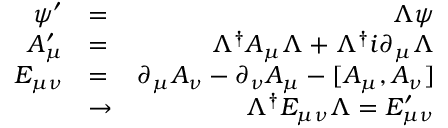<formula> <loc_0><loc_0><loc_500><loc_500>\begin{array} { r l r } { \psi ^ { \prime } } & { = } & { \Lambda \psi } \\ { A _ { \mu } ^ { \prime } } & { = } & { \Lambda ^ { \dagger } A _ { \mu } \Lambda + \Lambda ^ { \dagger } i \partial _ { \mu } \Lambda } \\ { E _ { \mu \nu } } & { = } & { \partial _ { \mu } A _ { \nu } - \partial _ { \nu } A _ { \mu } - [ A _ { \mu } , A _ { \nu } ] } \\ & { \to } & { \Lambda ^ { \dagger } E _ { \mu \nu } \Lambda = E _ { \mu \nu } ^ { \prime } } \end{array}</formula> 